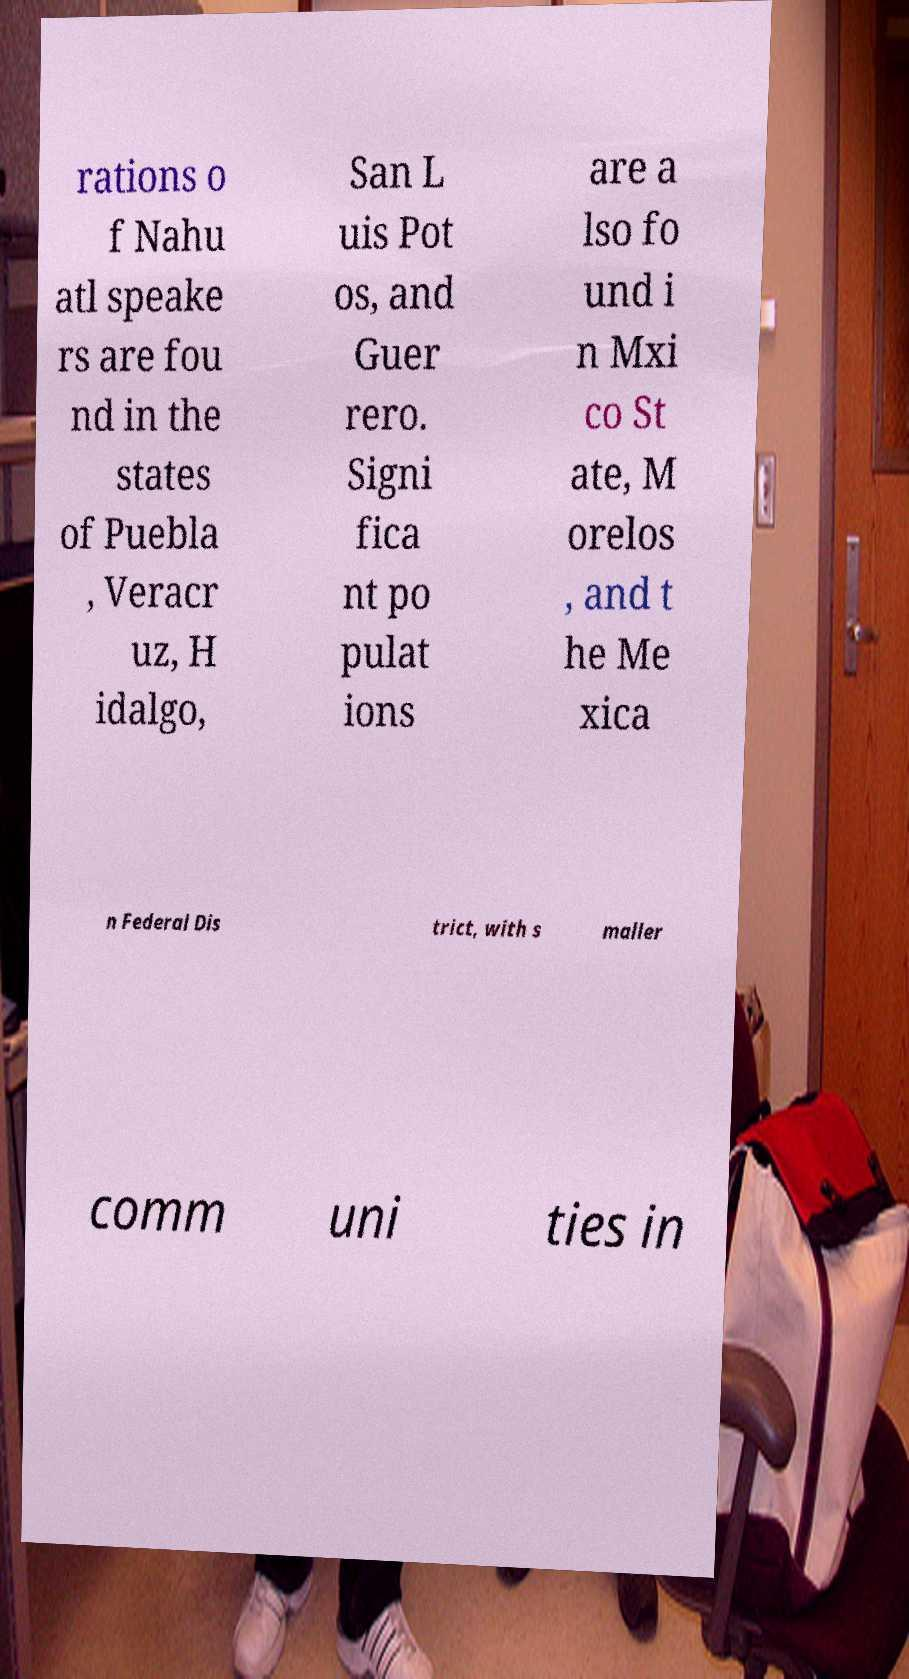Please read and relay the text visible in this image. What does it say? rations o f Nahu atl speake rs are fou nd in the states of Puebla , Veracr uz, H idalgo, San L uis Pot os, and Guer rero. Signi fica nt po pulat ions are a lso fo und i n Mxi co St ate, M orelos , and t he Me xica n Federal Dis trict, with s maller comm uni ties in 